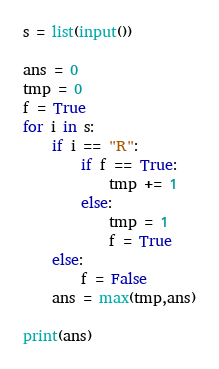Convert code to text. <code><loc_0><loc_0><loc_500><loc_500><_Python_>s = list(input())

ans = 0
tmp = 0
f = True
for i in s:
    if i == "R":
        if f == True:
            tmp += 1
        else:
            tmp = 1
            f = True
    else:
        f = False
    ans = max(tmp,ans)

print(ans)</code> 